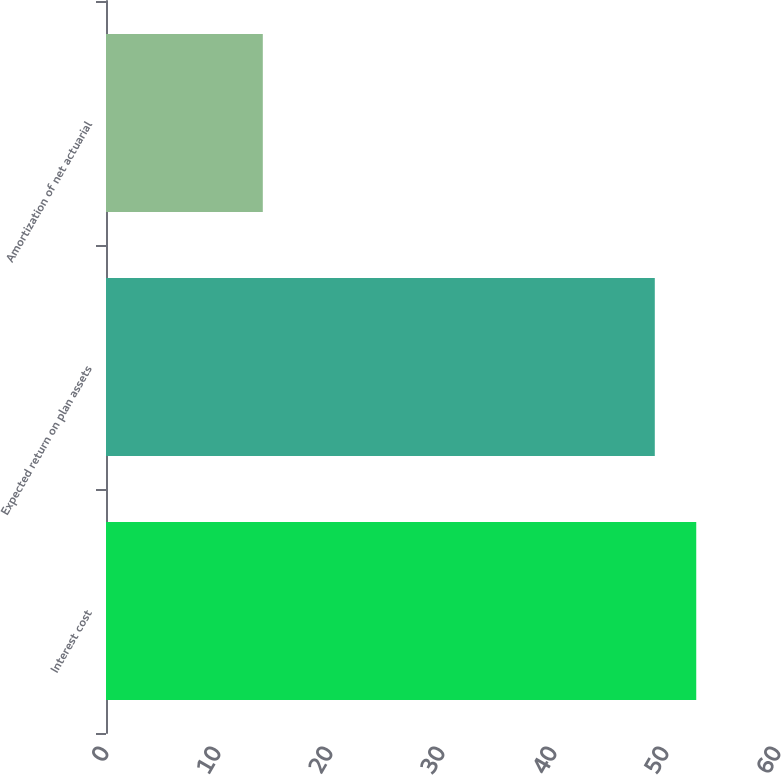Convert chart to OTSL. <chart><loc_0><loc_0><loc_500><loc_500><bar_chart><fcel>Interest cost<fcel>Expected return on plan assets<fcel>Amortization of net actuarial<nl><fcel>52.7<fcel>49<fcel>14<nl></chart> 